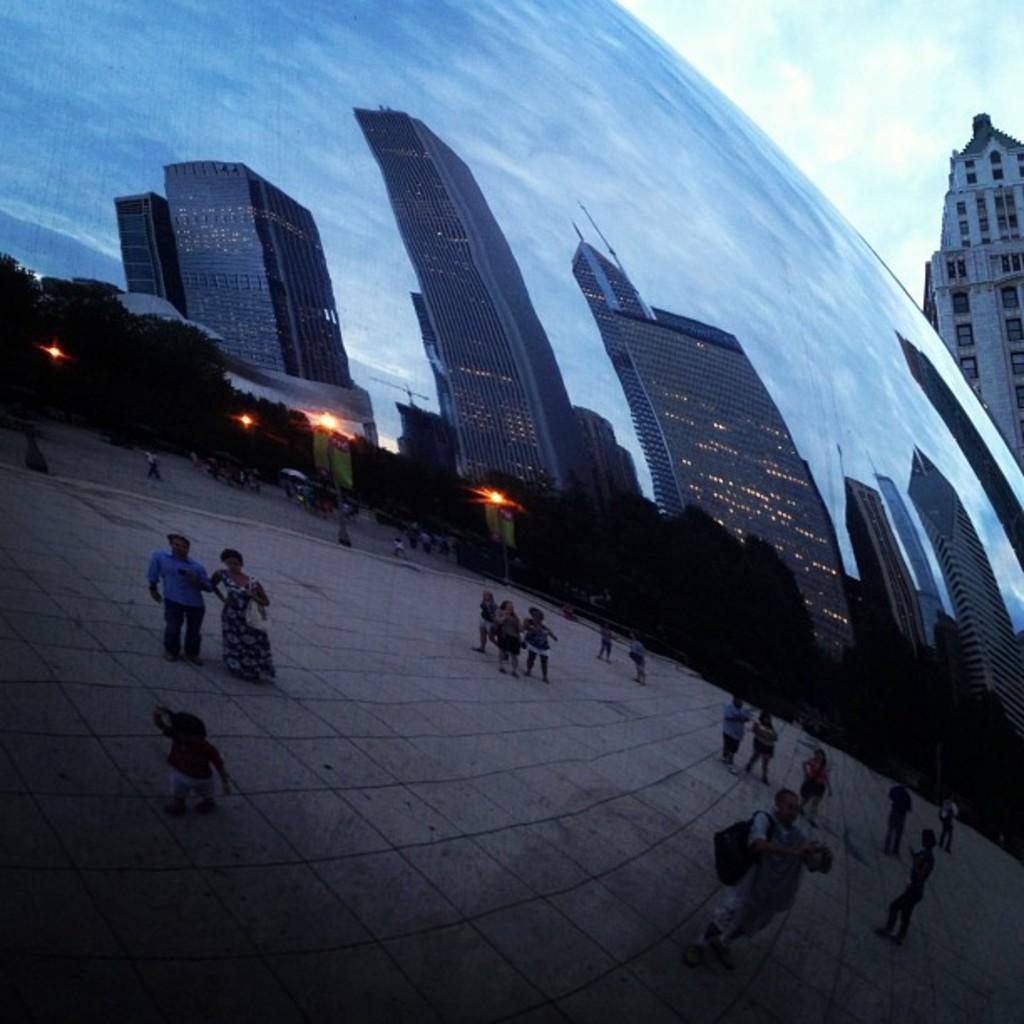In one or two sentences, can you explain what this image depicts? As we can see in the image there are buildings, trees, lights, few people here and there and on the top there is sky. 